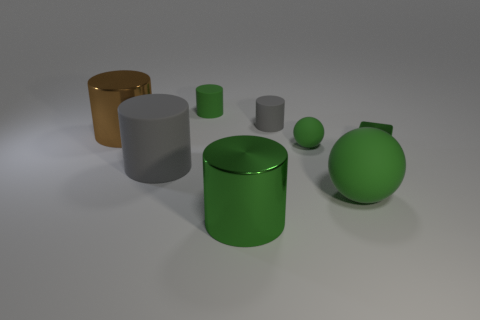What is the texture of the objects, and how does the light in the scene affect their appearance? The objects have a smooth, reflective surface suggesting a metallic or polished material. The light casts soft shadows and highlights the curves and edges of the objects, enhancing their three-dimensional appearance. 